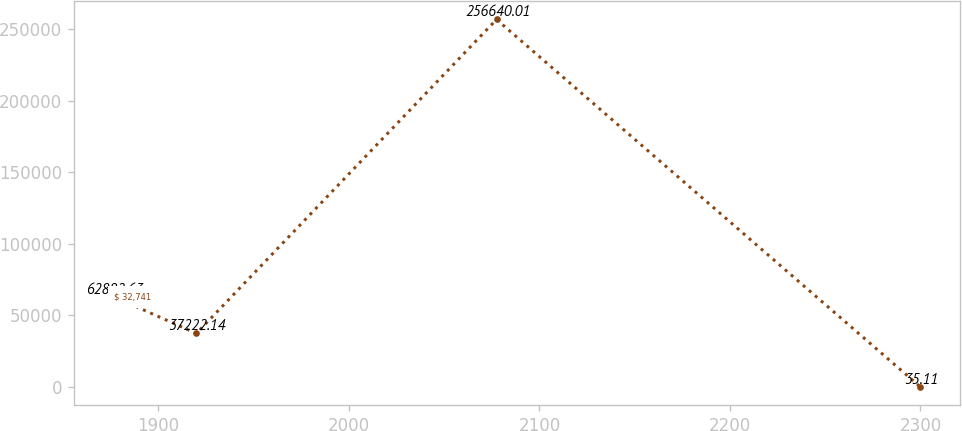Convert chart to OTSL. <chart><loc_0><loc_0><loc_500><loc_500><line_chart><ecel><fcel>$ 32,741<nl><fcel>1876.63<fcel>62882.6<nl><fcel>1919.9<fcel>37222.1<nl><fcel>2077.47<fcel>256640<nl><fcel>2299.83<fcel>35.11<nl></chart> 